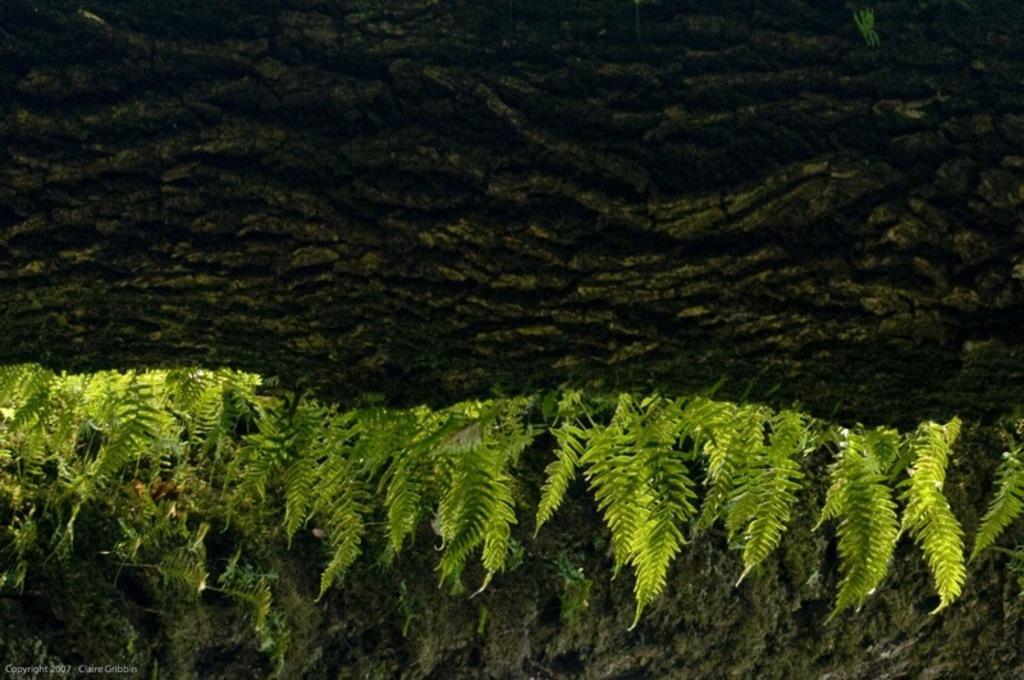Please provide a concise description of this image. This image consists of green plants along with the ground. 